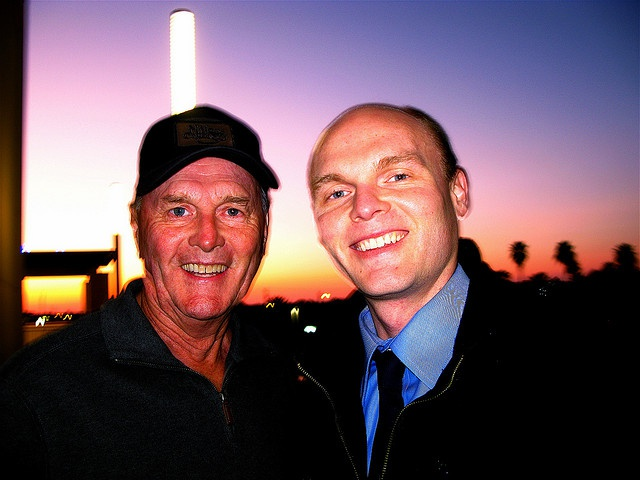Describe the objects in this image and their specific colors. I can see people in black and salmon tones, people in black, salmon, maroon, and brown tones, and tie in black, navy, blue, and darkblue tones in this image. 